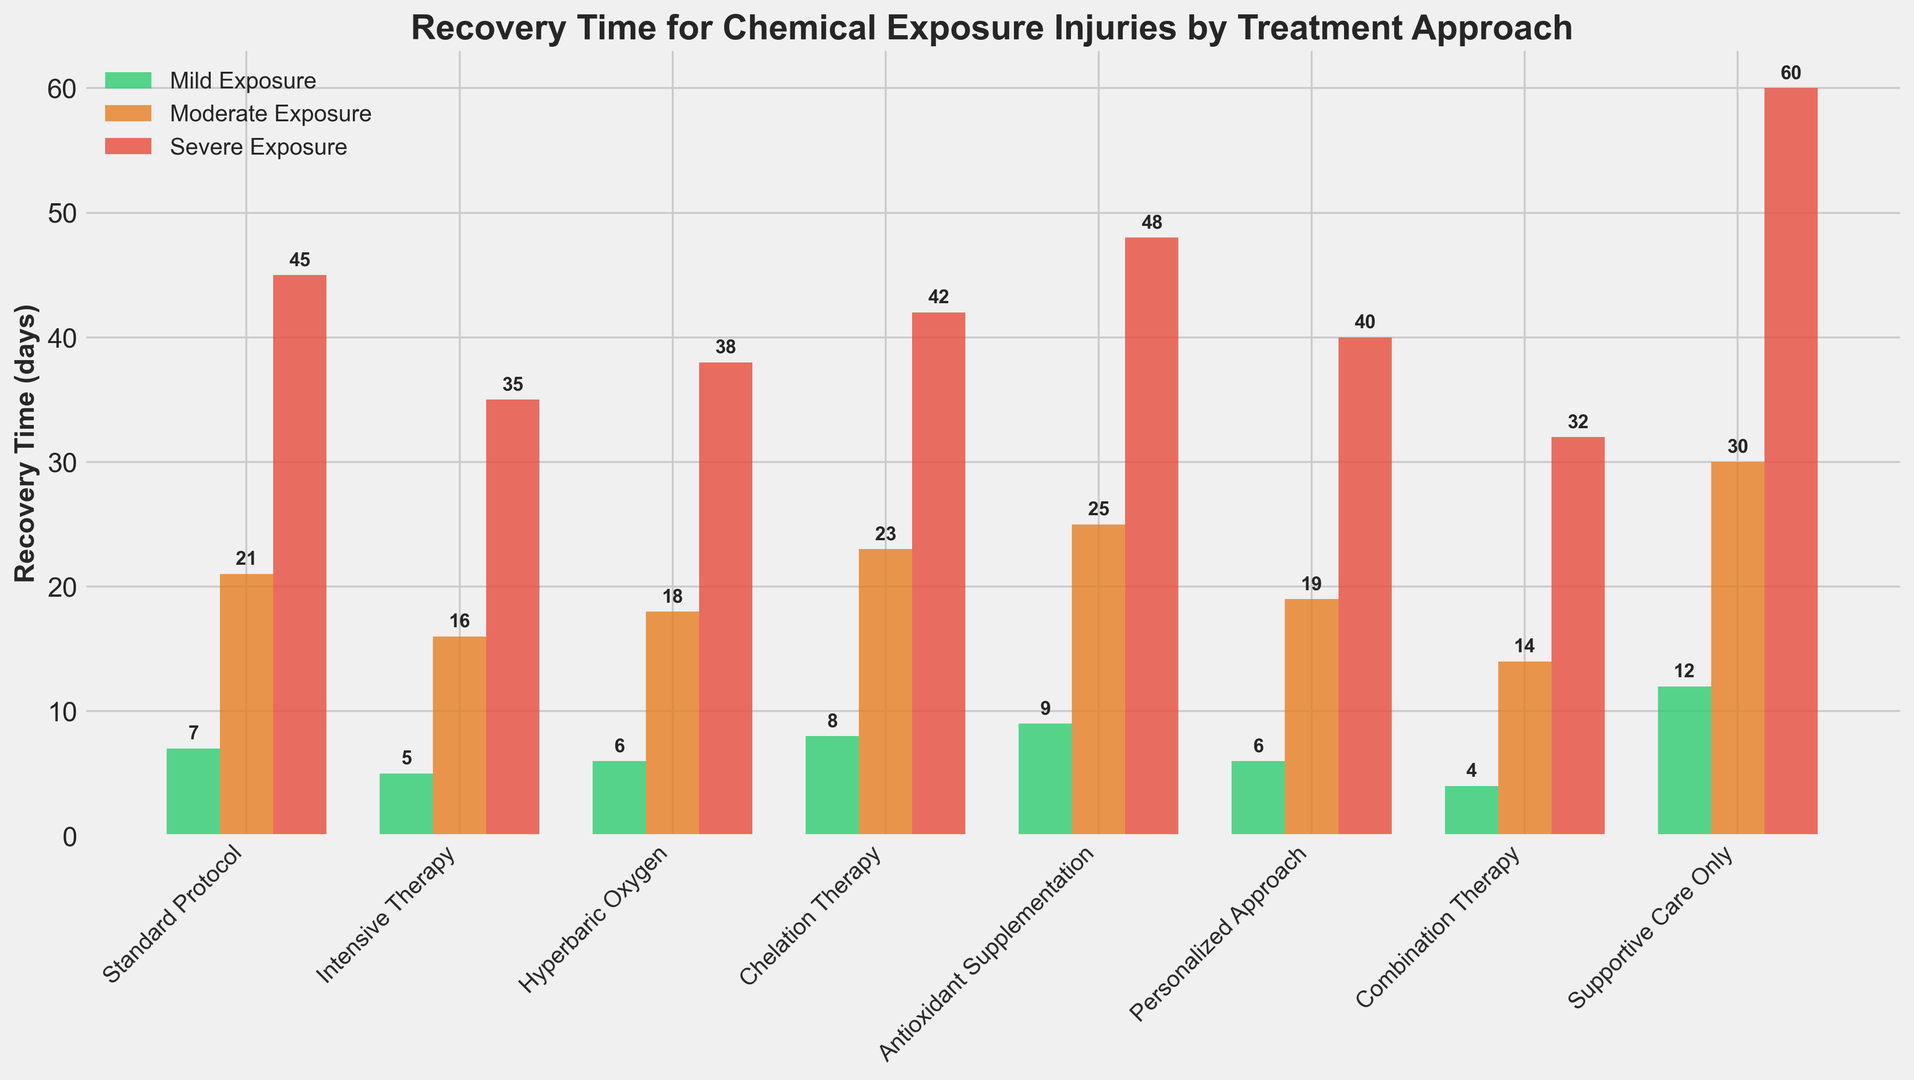Which treatment approach has the shortest recovery time for severe exposure? The shortest bar in the red (severe exposure) category represents the treatment approach with the shortest recovery time. The bar for "Combination Therapy" is the shortest with 32 days.
Answer: Combination Therapy How many days more does Antioxidant Supplementation take for mild exposure compared to Standard Protocol? Look at the green (mild exposure) bars for Antioxidant Supplementation and Standard Protocol. The Antioxidant Supplementation bar is 9 days, and the Standard Protocol bar is 7 days. The difference is 9 - 7 = 2 days.
Answer: 2 Which treatment has the largest range of recovery times between mild and severe exposure? Calculate the range by subtracting the mild exposure days from the severe exposure days for each treatment. The largest range is observed in Supportive Care Only with a range of 60 - 12 = 48 days.
Answer: Supportive Care Only In moderate exposure, which treatment is less effective: Standard Protocol or Personalized Approach? Compare the orange (moderate exposure) bars for Standard Protocol and Personalized Approach. Standard Protocol has 21 days and Personalized Approach has 19 days. Therefore, Standard Protocol is less effective.
Answer: Standard Protocol What is the combined recovery time for mild exposure across all treatments? Sum the green (mild exposure) bars for all treatments: 7 + 5 + 6 + 8 + 9 + 6 + 4 + 12 = 57 days.
Answer: 57 days For severe exposure, by how many days does Combination Therapy outperform Chelation Therapy? Look at the red (severe exposure) bars for Combination Therapy and Chelation Therapy. Combination Therapy is 32 days, and Chelation Therapy is 42 days. The difference is 42 - 32 = 10 days.
Answer: 10 days Which treatment approach shows an equal recovery time for both mild and severe exposure? No bars in the red (severe exposure) and green (mild exposure) categories have the same height, indicating there is no treatment with an equal recovery time for both exposure levels.
Answer: None What is the average recovery time for moderate exposure across all treatments? Sum the orange (moderate exposure) bars for all treatments and divide by the number of treatments: (21 + 16 + 18 + 23 + 25 + 19 + 14 + 30) / 8 = 20.75 days.
Answer: 20.75 days Which treatment method results in the quickest recovery time overall? Find the shortest bar in all categories (green, orange, red). The shortest bar overall is 4 days, which belongs to Combination Therapy for mild exposure.
Answer: Combination Therapy 